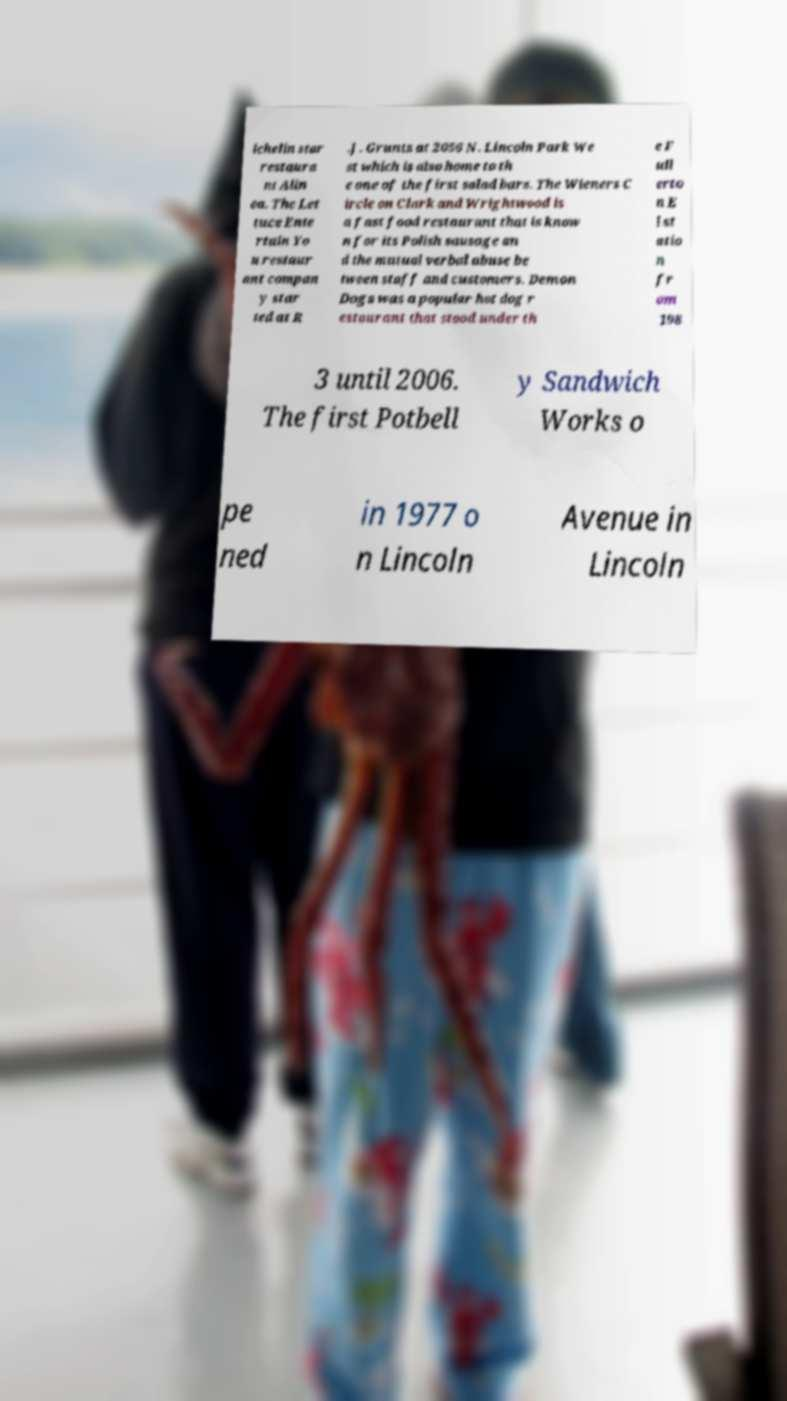Can you read and provide the text displayed in the image?This photo seems to have some interesting text. Can you extract and type it out for me? ichelin star restaura nt Alin ea. The Let tuce Ente rtain Yo u restaur ant compan y star ted at R .J. Grunts at 2056 N. Lincoln Park We st which is also home to th e one of the first salad bars. The Wieners C ircle on Clark and Wrightwood is a fast food restaurant that is know n for its Polish sausage an d the mutual verbal abuse be tween staff and customers. Demon Dogs was a popular hot dog r estaurant that stood under th e F ull erto n E l st atio n fr om 198 3 until 2006. The first Potbell y Sandwich Works o pe ned in 1977 o n Lincoln Avenue in Lincoln 